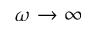Convert formula to latex. <formula><loc_0><loc_0><loc_500><loc_500>\omega \rightarrow \infty</formula> 